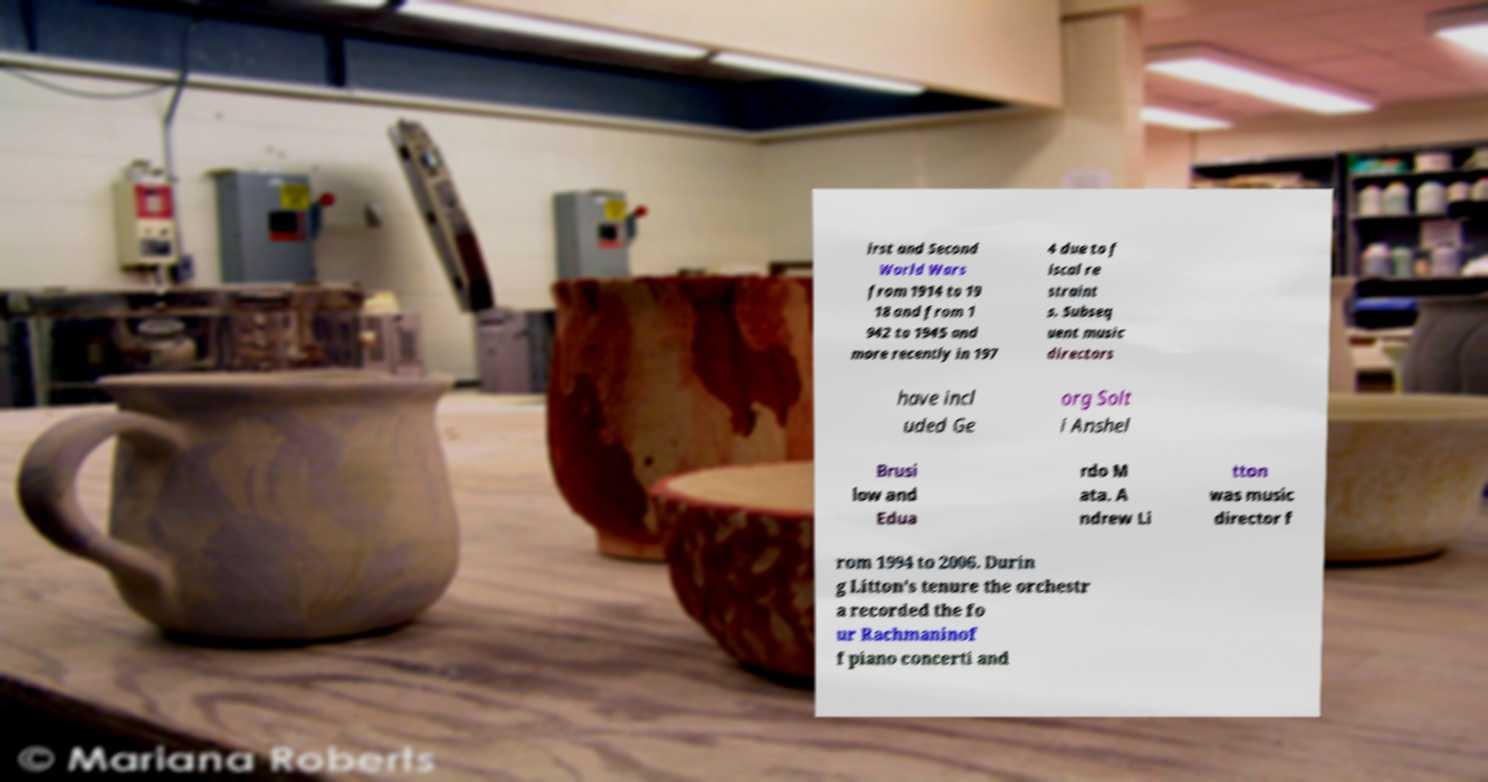Could you assist in decoding the text presented in this image and type it out clearly? irst and Second World Wars from 1914 to 19 18 and from 1 942 to 1945 and more recently in 197 4 due to f iscal re straint s. Subseq uent music directors have incl uded Ge org Solt i Anshel Brusi low and Edua rdo M ata. A ndrew Li tton was music director f rom 1994 to 2006. Durin g Litton's tenure the orchestr a recorded the fo ur Rachmaninof f piano concerti and 